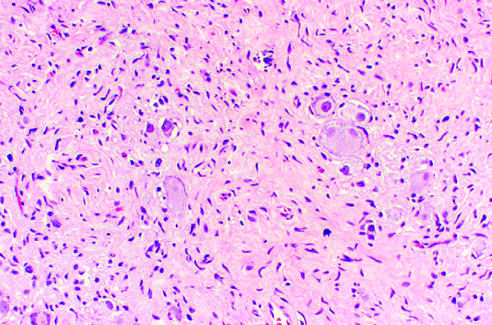what are characterized by clusters of large ganglion cells with vesicular nuclei and abundant eosinophilic cytoplasm arrow?
Answer the question using a single word or phrase. Ganglioneuromas 